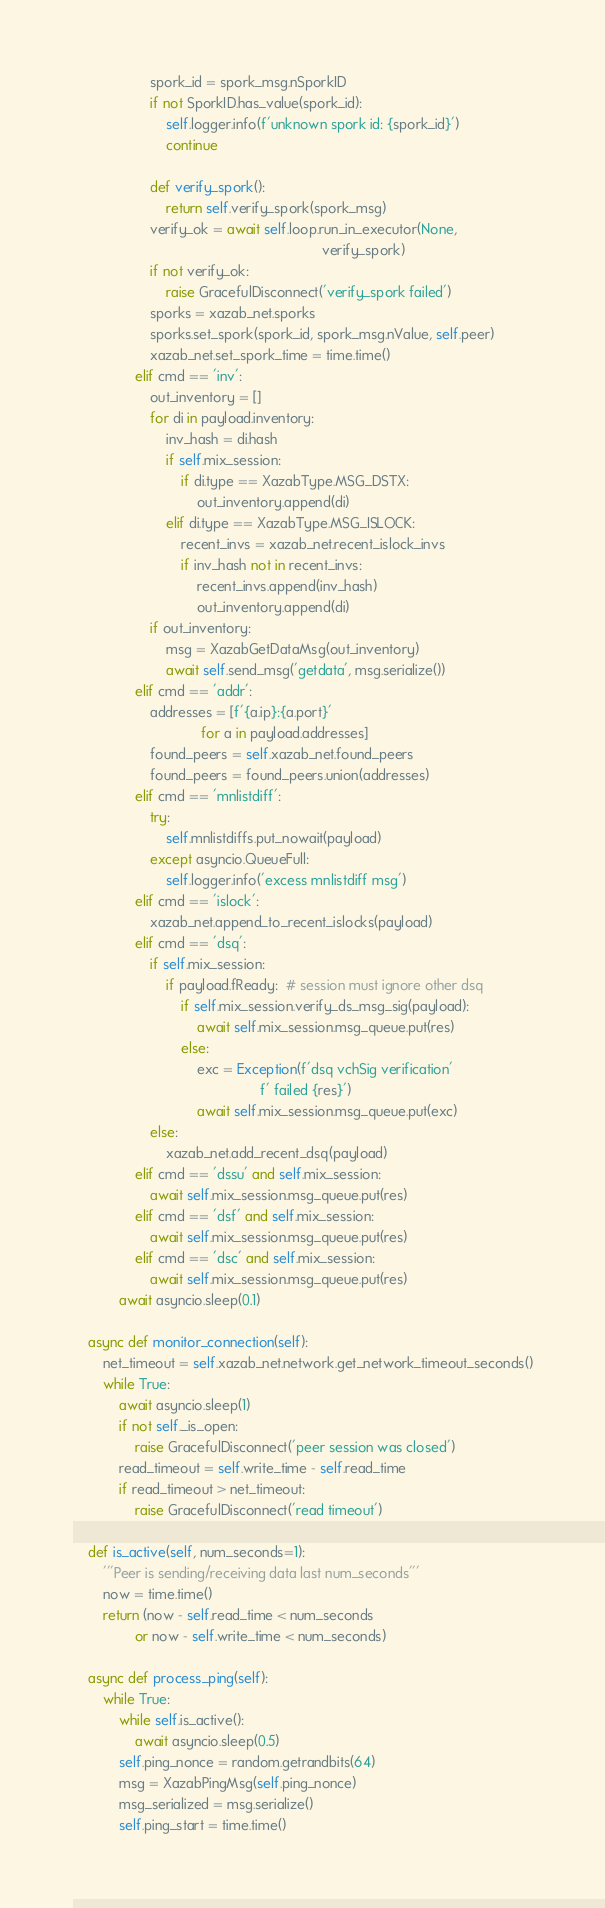<code> <loc_0><loc_0><loc_500><loc_500><_Python_>                    spork_id = spork_msg.nSporkID
                    if not SporkID.has_value(spork_id):
                        self.logger.info(f'unknown spork id: {spork_id}')
                        continue

                    def verify_spork():
                        return self.verify_spork(spork_msg)
                    verify_ok = await self.loop.run_in_executor(None,
                                                                verify_spork)
                    if not verify_ok:
                        raise GracefulDisconnect('verify_spork failed')
                    sporks = xazab_net.sporks
                    sporks.set_spork(spork_id, spork_msg.nValue, self.peer)
                    xazab_net.set_spork_time = time.time()
                elif cmd == 'inv':
                    out_inventory = []
                    for di in payload.inventory:
                        inv_hash = di.hash
                        if self.mix_session:
                            if di.type == XazabType.MSG_DSTX:
                                out_inventory.append(di)
                        elif di.type == XazabType.MSG_ISLOCK:
                            recent_invs = xazab_net.recent_islock_invs
                            if inv_hash not in recent_invs:
                                recent_invs.append(inv_hash)
                                out_inventory.append(di)
                    if out_inventory:
                        msg = XazabGetDataMsg(out_inventory)
                        await self.send_msg('getdata', msg.serialize())
                elif cmd == 'addr':
                    addresses = [f'{a.ip}:{a.port}'
                                 for a in payload.addresses]
                    found_peers = self.xazab_net.found_peers
                    found_peers = found_peers.union(addresses)
                elif cmd == 'mnlistdiff':
                    try:
                        self.mnlistdiffs.put_nowait(payload)
                    except asyncio.QueueFull:
                        self.logger.info('excess mnlistdiff msg')
                elif cmd == 'islock':
                    xazab_net.append_to_recent_islocks(payload)
                elif cmd == 'dsq':
                    if self.mix_session:
                        if payload.fReady:  # session must ignore other dsq
                            if self.mix_session.verify_ds_msg_sig(payload):
                                await self.mix_session.msg_queue.put(res)
                            else:
                                exc = Exception(f'dsq vchSig verification'
                                                f' failed {res}')
                                await self.mix_session.msg_queue.put(exc)
                    else:
                        xazab_net.add_recent_dsq(payload)
                elif cmd == 'dssu' and self.mix_session:
                    await self.mix_session.msg_queue.put(res)
                elif cmd == 'dsf' and self.mix_session:
                    await self.mix_session.msg_queue.put(res)
                elif cmd == 'dsc' and self.mix_session:
                    await self.mix_session.msg_queue.put(res)
            await asyncio.sleep(0.1)

    async def monitor_connection(self):
        net_timeout = self.xazab_net.network.get_network_timeout_seconds()
        while True:
            await asyncio.sleep(1)
            if not self._is_open:
                raise GracefulDisconnect('peer session was closed')
            read_timeout = self.write_time - self.read_time
            if read_timeout > net_timeout:
                raise GracefulDisconnect('read timeout')

    def is_active(self, num_seconds=1):
        '''Peer is sending/receiving data last num_seconds'''
        now = time.time()
        return (now - self.read_time < num_seconds
                or now - self.write_time < num_seconds)

    async def process_ping(self):
        while True:
            while self.is_active():
                await asyncio.sleep(0.5)
            self.ping_nonce = random.getrandbits(64)
            msg = XazabPingMsg(self.ping_nonce)
            msg_serialized = msg.serialize()
            self.ping_start = time.time()</code> 